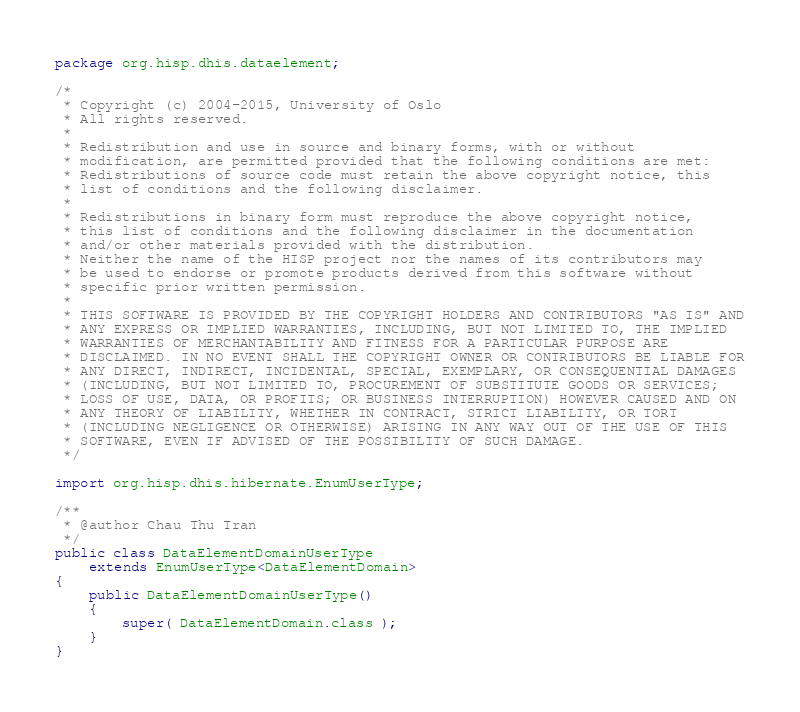Convert code to text. <code><loc_0><loc_0><loc_500><loc_500><_Java_>package org.hisp.dhis.dataelement;

/*
 * Copyright (c) 2004-2015, University of Oslo
 * All rights reserved.
 *
 * Redistribution and use in source and binary forms, with or without
 * modification, are permitted provided that the following conditions are met:
 * Redistributions of source code must retain the above copyright notice, this
 * list of conditions and the following disclaimer.
 *
 * Redistributions in binary form must reproduce the above copyright notice,
 * this list of conditions and the following disclaimer in the documentation
 * and/or other materials provided with the distribution.
 * Neither the name of the HISP project nor the names of its contributors may
 * be used to endorse or promote products derived from this software without
 * specific prior written permission.
 *
 * THIS SOFTWARE IS PROVIDED BY THE COPYRIGHT HOLDERS AND CONTRIBUTORS "AS IS" AND
 * ANY EXPRESS OR IMPLIED WARRANTIES, INCLUDING, BUT NOT LIMITED TO, THE IMPLIED
 * WARRANTIES OF MERCHANTABILITY AND FITNESS FOR A PARTICULAR PURPOSE ARE
 * DISCLAIMED. IN NO EVENT SHALL THE COPYRIGHT OWNER OR CONTRIBUTORS BE LIABLE FOR
 * ANY DIRECT, INDIRECT, INCIDENTAL, SPECIAL, EXEMPLARY, OR CONSEQUENTIAL DAMAGES
 * (INCLUDING, BUT NOT LIMITED TO, PROCUREMENT OF SUBSTITUTE GOODS OR SERVICES;
 * LOSS OF USE, DATA, OR PROFITS; OR BUSINESS INTERRUPTION) HOWEVER CAUSED AND ON
 * ANY THEORY OF LIABILITY, WHETHER IN CONTRACT, STRICT LIABILITY, OR TORT
 * (INCLUDING NEGLIGENCE OR OTHERWISE) ARISING IN ANY WAY OUT OF THE USE OF THIS
 * SOFTWARE, EVEN IF ADVISED OF THE POSSIBILITY OF SUCH DAMAGE.
 */

import org.hisp.dhis.hibernate.EnumUserType;

/**
 * @author Chau Thu Tran
 */
public class DataElementDomainUserType
    extends EnumUserType<DataElementDomain>
{
    public DataElementDomainUserType()
    {
        super( DataElementDomain.class );
    }
}
</code> 